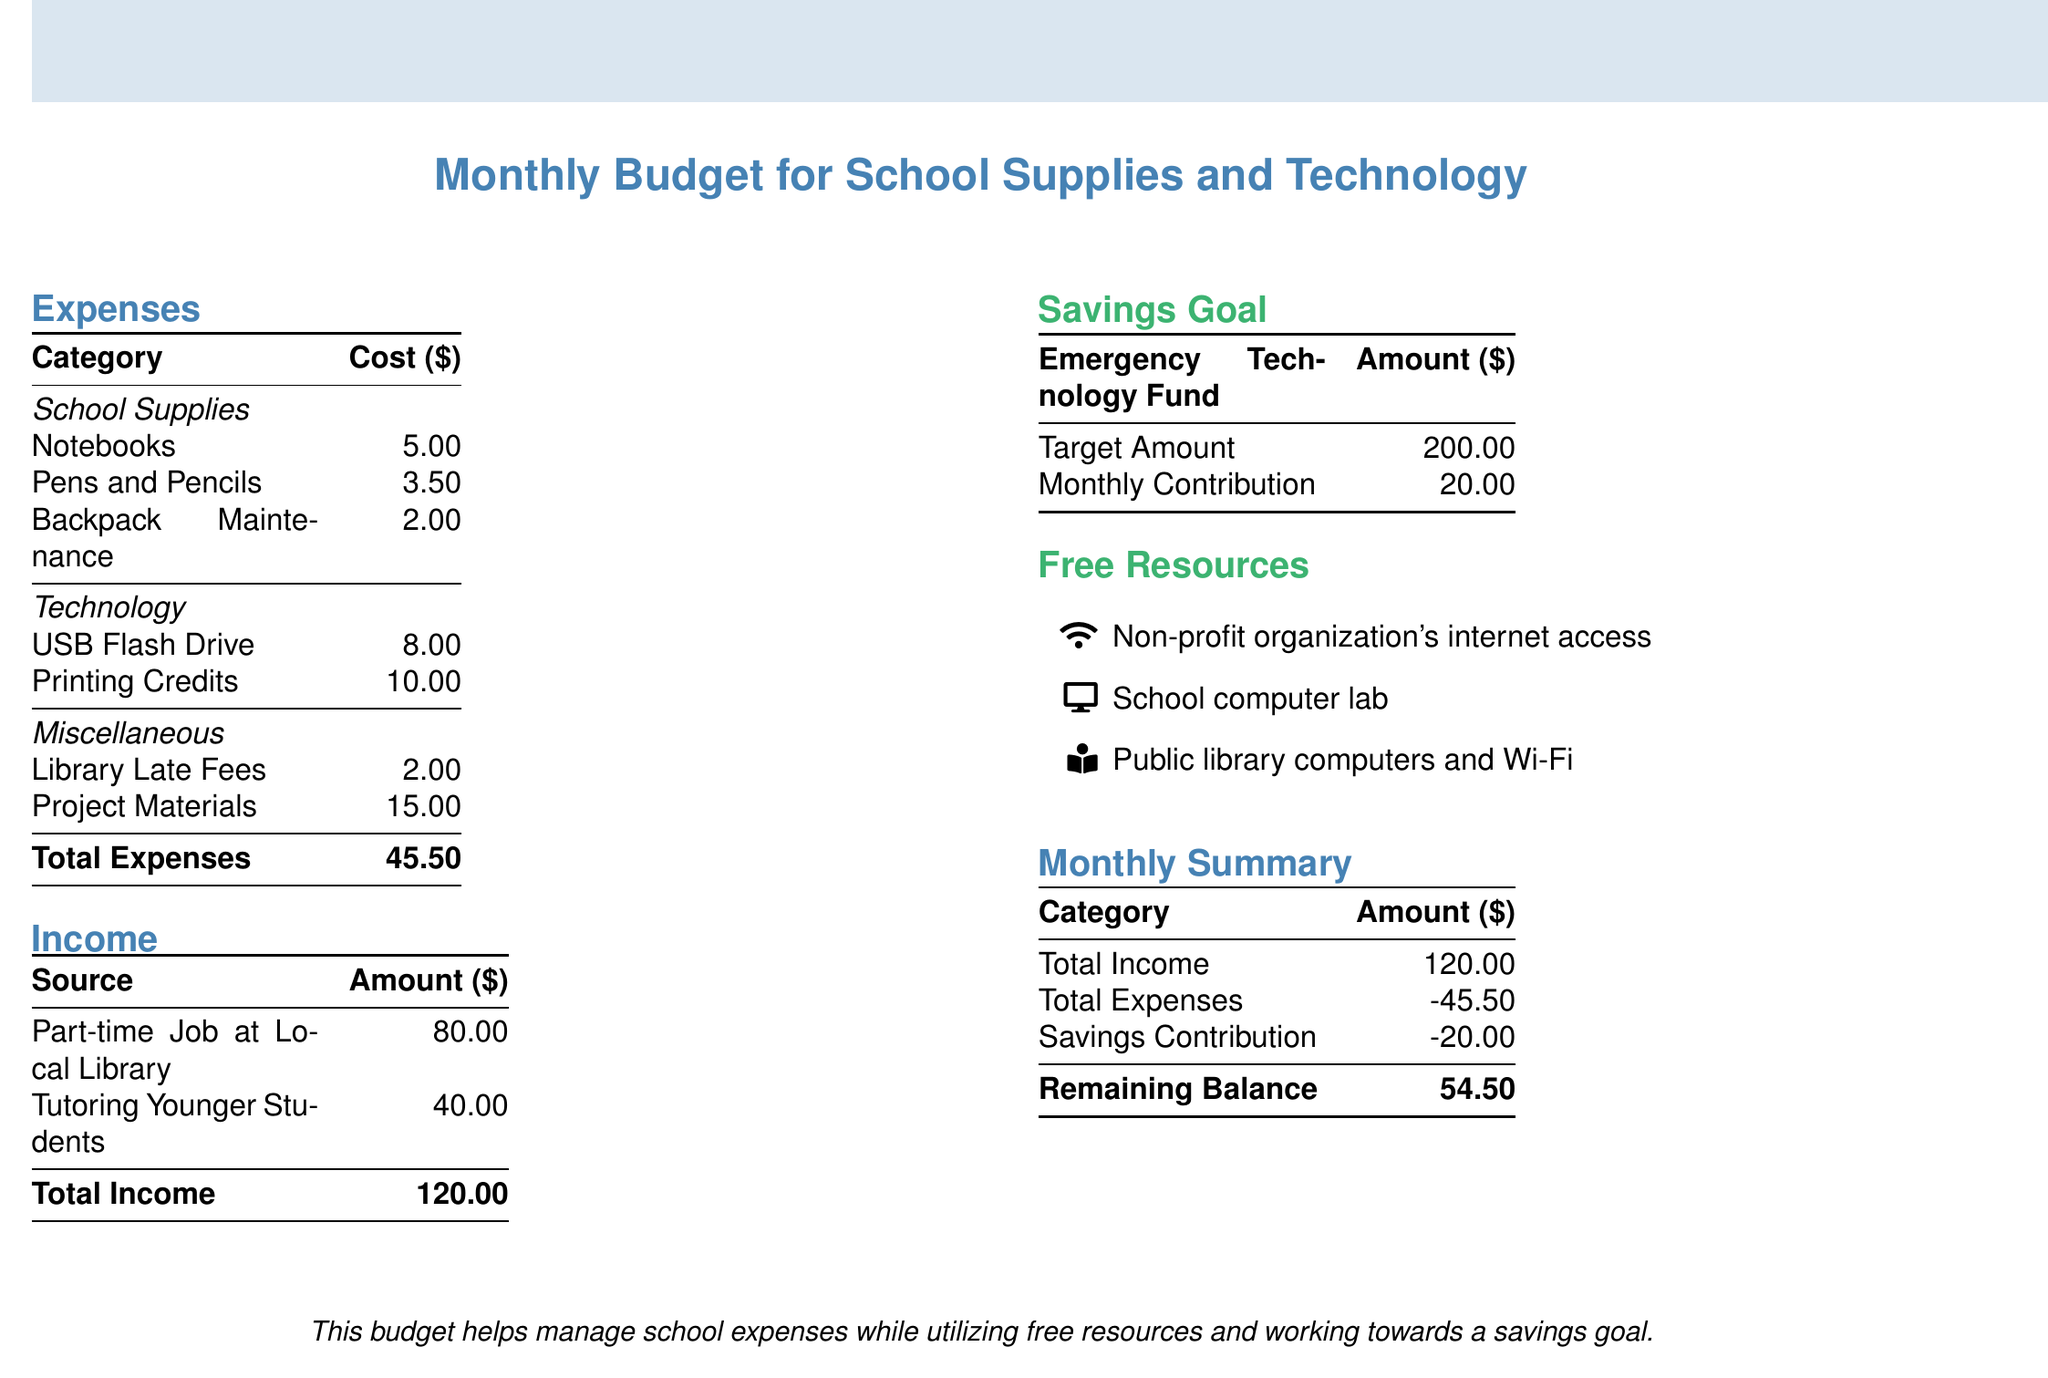what is the total cost of school supplies? The total cost of school supplies is found by adding the costs of notebooks, pens and pencils, and backpack maintenance, which comes to $5.00 + $3.50 + $2.00 = $10.50.
Answer: $10.50 what is the monthly contribution to the emergency technology fund? The monthly contribution to the emergency technology fund is specified directly in the document.
Answer: $20.00 how much does the part-time job at the local library contribute? The contribution from the part-time job at the local library is stated in the income section of the document.
Answer: $80.00 what is the total income amount? The total income is calculated by summing the contributions from both income sources: part-time job and tutoring, which totals $80.00 + $40.00.
Answer: $120.00 how much is spent on printing credits? The amount spent on printing credits is indicated in the expenses section.
Answer: $10.00 what is the remaining balance after expenses and savings contribution? The remaining balance is calculated by taking the total income and subtracting total expenses and savings contribution: $120.00 - $45.50 - $20.00.
Answer: $54.50 how much are library late fees? The cost of library late fees is listed under miscellaneous expenses in the document.
Answer: $2.00 what is the target amount for the emergency technology fund? The target amount for the emergency technology fund is stated in the savings goal section.
Answer: $200.00 how much do project materials cost? The cost of project materials is found in the miscellaneous expenses section of the document.
Answer: $15.00 